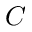<formula> <loc_0><loc_0><loc_500><loc_500>C</formula> 